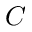<formula> <loc_0><loc_0><loc_500><loc_500>C</formula> 